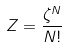<formula> <loc_0><loc_0><loc_500><loc_500>Z = \frac { \zeta ^ { N } } { N ! }</formula> 